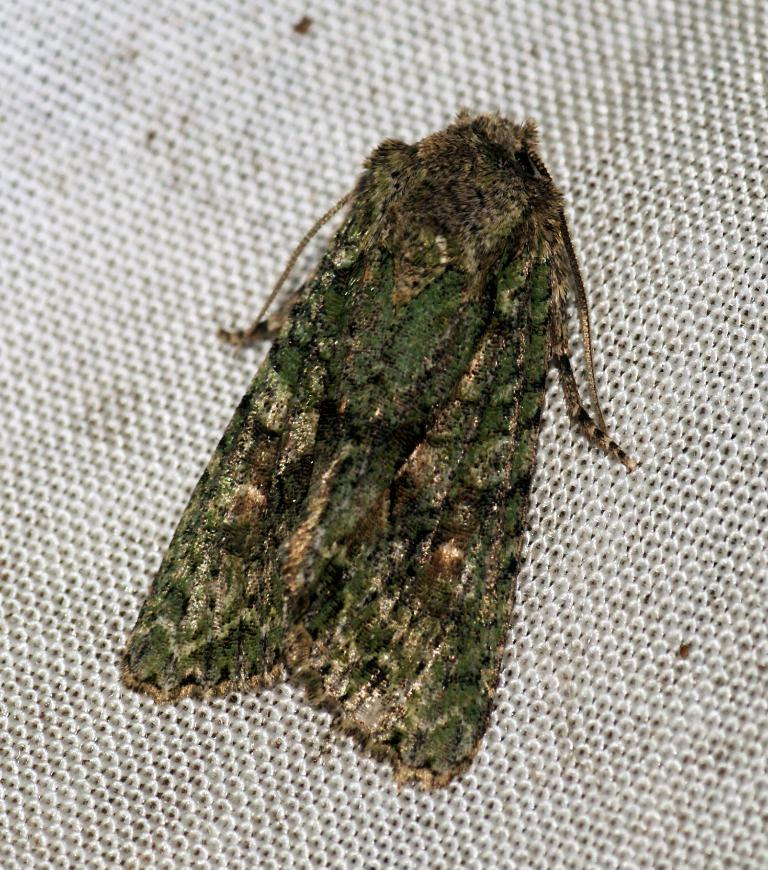What is the main subject in the center of the image? There is an insect in the center of the image. What else can be seen at the bottom of the image? There is a piece of cloth at the bottom of the image. What type of crate is being used to measure the insect in the image? There is no crate present in the image, and the insect is not being measured. 